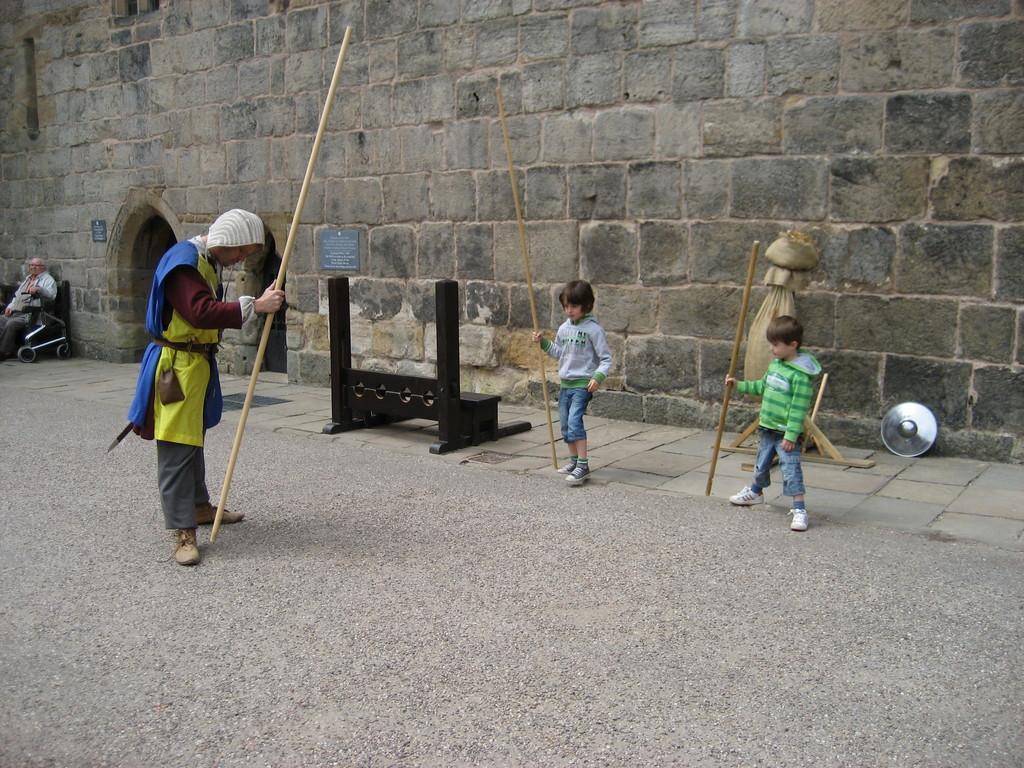Could you give a brief overview of what you see in this image? In this image there is a man and two children's are holding sticks in their hands, in the background there is a wall for that wall there is an entrance and there is a wooden bench and a man sitting on a chair. 